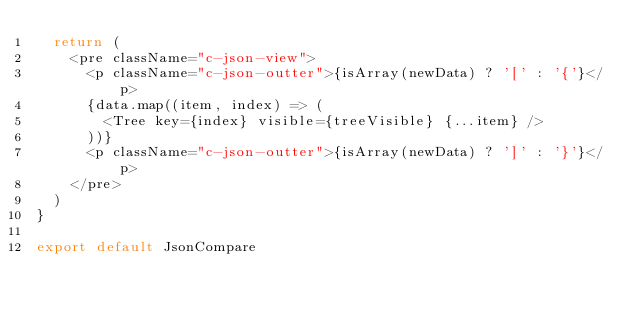Convert code to text. <code><loc_0><loc_0><loc_500><loc_500><_JavaScript_>  return (
    <pre className="c-json-view">
      <p className="c-json-outter">{isArray(newData) ? '[' : '{'}</p>
      {data.map((item, index) => (
        <Tree key={index} visible={treeVisible} {...item} />
      ))}
      <p className="c-json-outter">{isArray(newData) ? ']' : '}'}</p>
    </pre>
  )
}

export default JsonCompare
</code> 